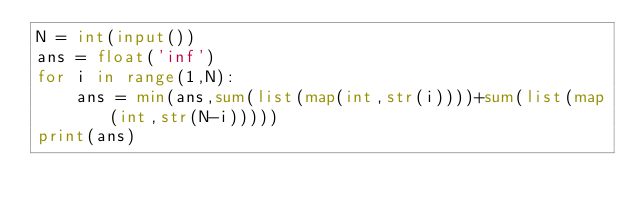Convert code to text. <code><loc_0><loc_0><loc_500><loc_500><_Python_>N = int(input())
ans = float('inf')
for i in range(1,N):
    ans = min(ans,sum(list(map(int,str(i))))+sum(list(map(int,str(N-i)))))
print(ans)</code> 